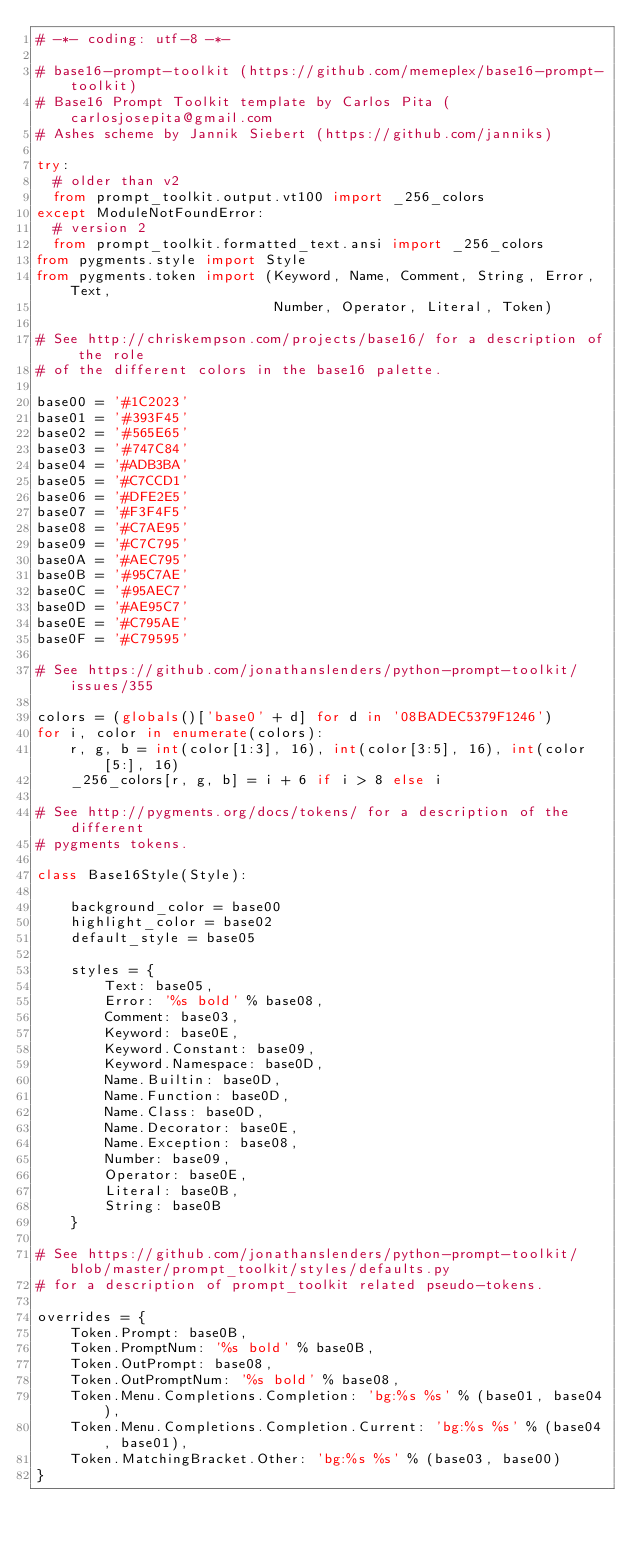Convert code to text. <code><loc_0><loc_0><loc_500><loc_500><_Python_># -*- coding: utf-8 -*-

# base16-prompt-toolkit (https://github.com/memeplex/base16-prompt-toolkit)
# Base16 Prompt Toolkit template by Carlos Pita (carlosjosepita@gmail.com
# Ashes scheme by Jannik Siebert (https://github.com/janniks)

try:
  # older than v2
  from prompt_toolkit.output.vt100 import _256_colors
except ModuleNotFoundError:
  # version 2
  from prompt_toolkit.formatted_text.ansi import _256_colors
from pygments.style import Style
from pygments.token import (Keyword, Name, Comment, String, Error, Text,
                            Number, Operator, Literal, Token)

# See http://chriskempson.com/projects/base16/ for a description of the role
# of the different colors in the base16 palette.

base00 = '#1C2023'
base01 = '#393F45'
base02 = '#565E65'
base03 = '#747C84'
base04 = '#ADB3BA'
base05 = '#C7CCD1'
base06 = '#DFE2E5'
base07 = '#F3F4F5'
base08 = '#C7AE95'
base09 = '#C7C795'
base0A = '#AEC795'
base0B = '#95C7AE'
base0C = '#95AEC7'
base0D = '#AE95C7'
base0E = '#C795AE'
base0F = '#C79595'

# See https://github.com/jonathanslenders/python-prompt-toolkit/issues/355

colors = (globals()['base0' + d] for d in '08BADEC5379F1246')
for i, color in enumerate(colors):
    r, g, b = int(color[1:3], 16), int(color[3:5], 16), int(color[5:], 16)
    _256_colors[r, g, b] = i + 6 if i > 8 else i

# See http://pygments.org/docs/tokens/ for a description of the different
# pygments tokens.

class Base16Style(Style):

    background_color = base00
    highlight_color = base02
    default_style = base05

    styles = {
        Text: base05,
        Error: '%s bold' % base08,
        Comment: base03,
        Keyword: base0E,
        Keyword.Constant: base09,
        Keyword.Namespace: base0D,
        Name.Builtin: base0D,
        Name.Function: base0D,
        Name.Class: base0D,
        Name.Decorator: base0E,
        Name.Exception: base08,
        Number: base09,
        Operator: base0E,
        Literal: base0B,
        String: base0B
    }

# See https://github.com/jonathanslenders/python-prompt-toolkit/blob/master/prompt_toolkit/styles/defaults.py
# for a description of prompt_toolkit related pseudo-tokens.

overrides = {
    Token.Prompt: base0B,
    Token.PromptNum: '%s bold' % base0B,
    Token.OutPrompt: base08,
    Token.OutPromptNum: '%s bold' % base08,
    Token.Menu.Completions.Completion: 'bg:%s %s' % (base01, base04),
    Token.Menu.Completions.Completion.Current: 'bg:%s %s' % (base04, base01),
    Token.MatchingBracket.Other: 'bg:%s %s' % (base03, base00)
}
</code> 